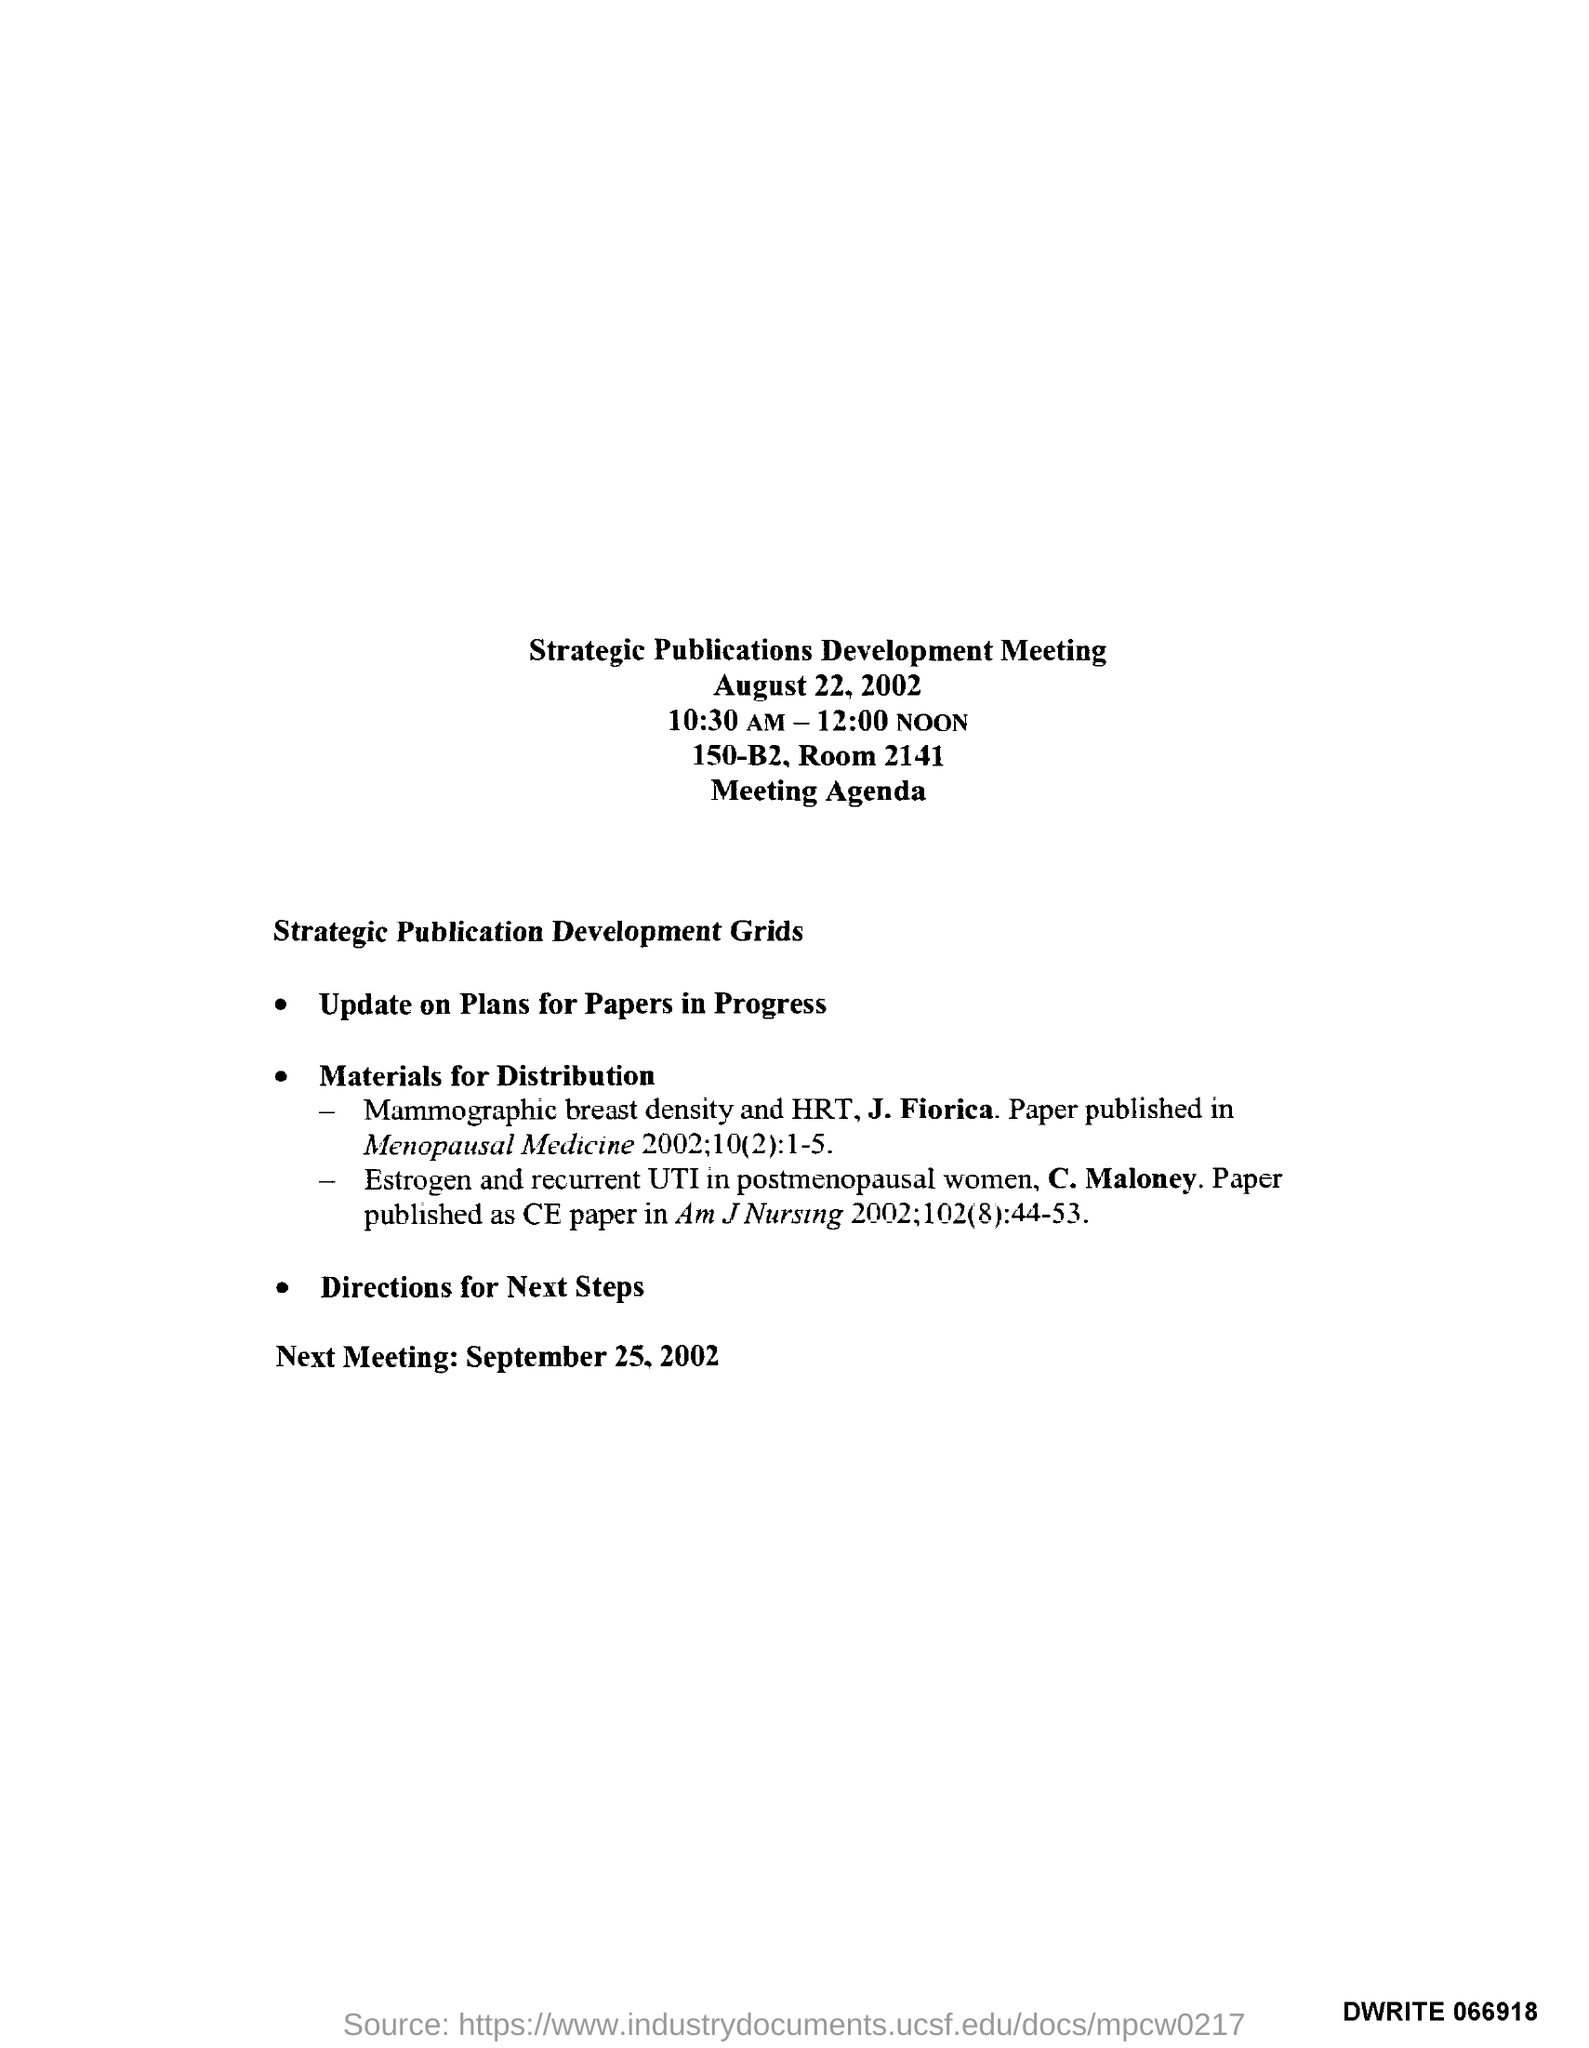What is the Room Number ?
Provide a succinct answer. 2141. What is the Date of Next Meeting ?
Your answer should be very brief. September 25, 2002. 